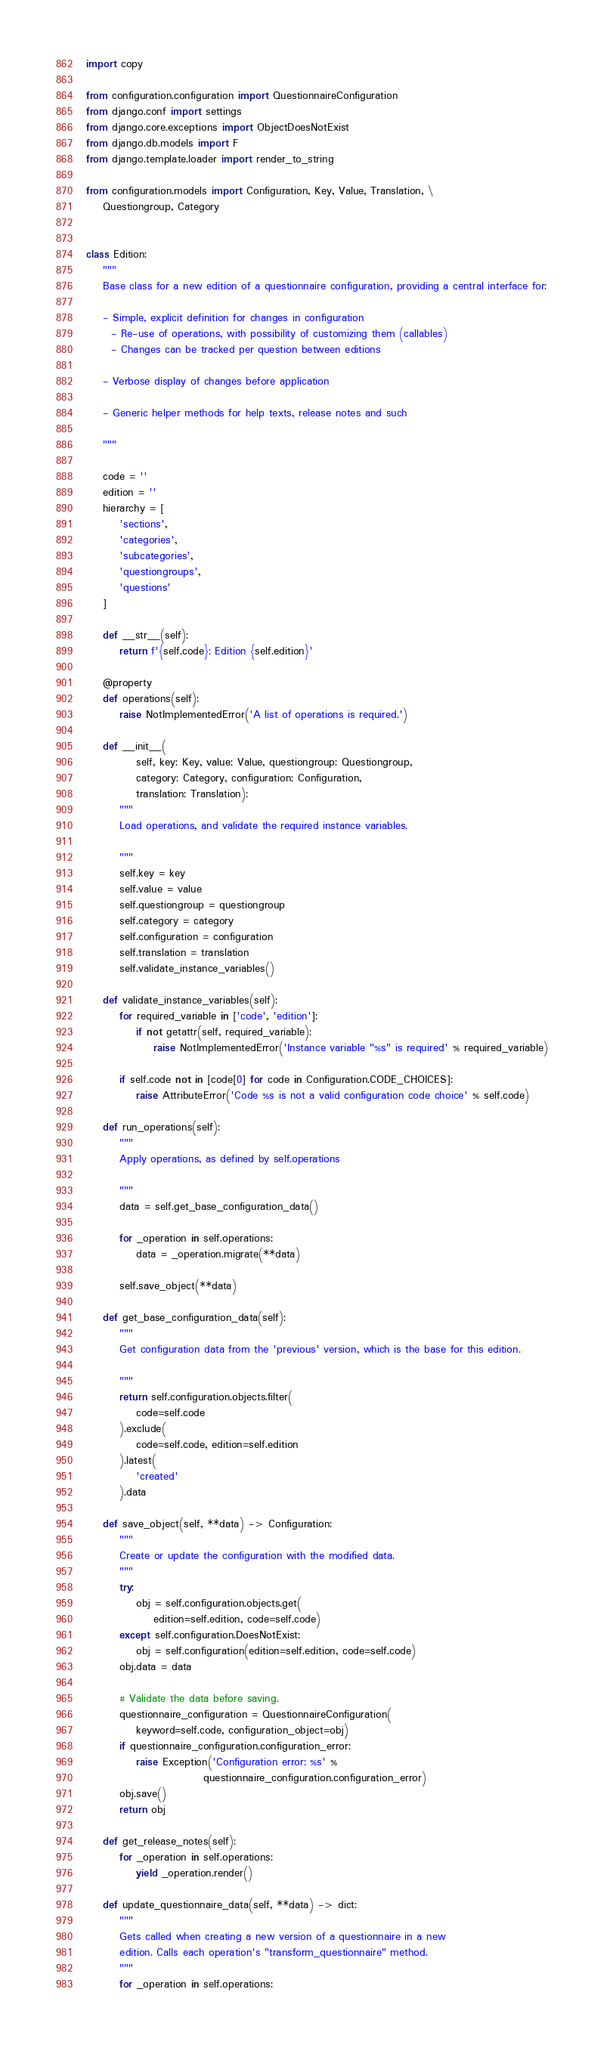<code> <loc_0><loc_0><loc_500><loc_500><_Python_>import copy

from configuration.configuration import QuestionnaireConfiguration
from django.conf import settings
from django.core.exceptions import ObjectDoesNotExist
from django.db.models import F
from django.template.loader import render_to_string

from configuration.models import Configuration, Key, Value, Translation, \
    Questiongroup, Category


class Edition:
    """
    Base class for a new edition of a questionnaire configuration, providing a central interface for:

    - Simple, explicit definition for changes in configuration
      - Re-use of operations, with possibility of customizing them (callables)
      - Changes can be tracked per question between editions

    - Verbose display of changes before application

    - Generic helper methods for help texts, release notes and such

    """

    code = ''
    edition = ''
    hierarchy = [
        'sections',
        'categories',
        'subcategories',
        'questiongroups',
        'questions'
    ]

    def __str__(self):
        return f'{self.code}: Edition {self.edition}'

    @property
    def operations(self):
        raise NotImplementedError('A list of operations is required.')

    def __init__(
            self, key: Key, value: Value, questiongroup: Questiongroup,
            category: Category, configuration: Configuration,
            translation: Translation):
        """
        Load operations, and validate the required instance variables.

        """
        self.key = key
        self.value = value
        self.questiongroup = questiongroup
        self.category = category
        self.configuration = configuration
        self.translation = translation
        self.validate_instance_variables()

    def validate_instance_variables(self):
        for required_variable in ['code', 'edition']:
            if not getattr(self, required_variable):
                raise NotImplementedError('Instance variable "%s" is required' % required_variable)

        if self.code not in [code[0] for code in Configuration.CODE_CHOICES]:
            raise AttributeError('Code %s is not a valid configuration code choice' % self.code)

    def run_operations(self):
        """
        Apply operations, as defined by self.operations

        """
        data = self.get_base_configuration_data()

        for _operation in self.operations:
            data = _operation.migrate(**data)

        self.save_object(**data)

    def get_base_configuration_data(self):
        """
        Get configuration data from the 'previous' version, which is the base for this edition.

        """
        return self.configuration.objects.filter(
            code=self.code
        ).exclude(
            code=self.code, edition=self.edition
        ).latest(
            'created'
        ).data

    def save_object(self, **data) -> Configuration:
        """
        Create or update the configuration with the modified data.
        """
        try:
            obj = self.configuration.objects.get(
                edition=self.edition, code=self.code)
        except self.configuration.DoesNotExist:
            obj = self.configuration(edition=self.edition, code=self.code)
        obj.data = data

        # Validate the data before saving.
        questionnaire_configuration = QuestionnaireConfiguration(
            keyword=self.code, configuration_object=obj)
        if questionnaire_configuration.configuration_error:
            raise Exception('Configuration error: %s' %
                            questionnaire_configuration.configuration_error)
        obj.save()
        return obj

    def get_release_notes(self):
        for _operation in self.operations:
            yield _operation.render()

    def update_questionnaire_data(self, **data) -> dict:
        """
        Gets called when creating a new version of a questionnaire in a new
        edition. Calls each operation's "transform_questionnaire" method.
        """
        for _operation in self.operations:</code> 